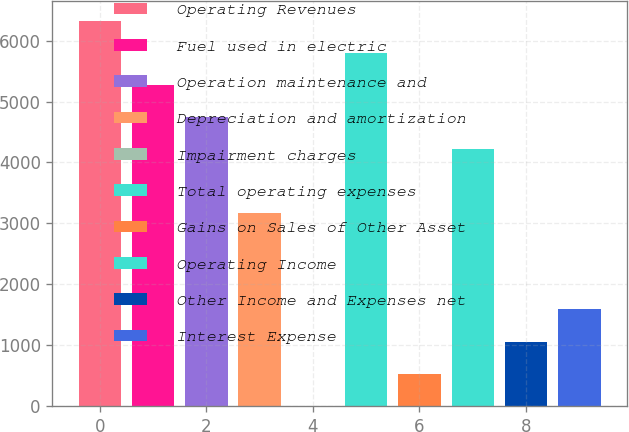Convert chart. <chart><loc_0><loc_0><loc_500><loc_500><bar_chart><fcel>Operating Revenues<fcel>Fuel used in electric<fcel>Operation maintenance and<fcel>Depreciation and amortization<fcel>Impairment charges<fcel>Total operating expenses<fcel>Gains on Sales of Other Asset<fcel>Operating Income<fcel>Other Income and Expenses net<fcel>Interest Expense<nl><fcel>6332.2<fcel>5277<fcel>4749.4<fcel>3166.6<fcel>1<fcel>5804.6<fcel>528.6<fcel>4221.8<fcel>1056.2<fcel>1583.8<nl></chart> 